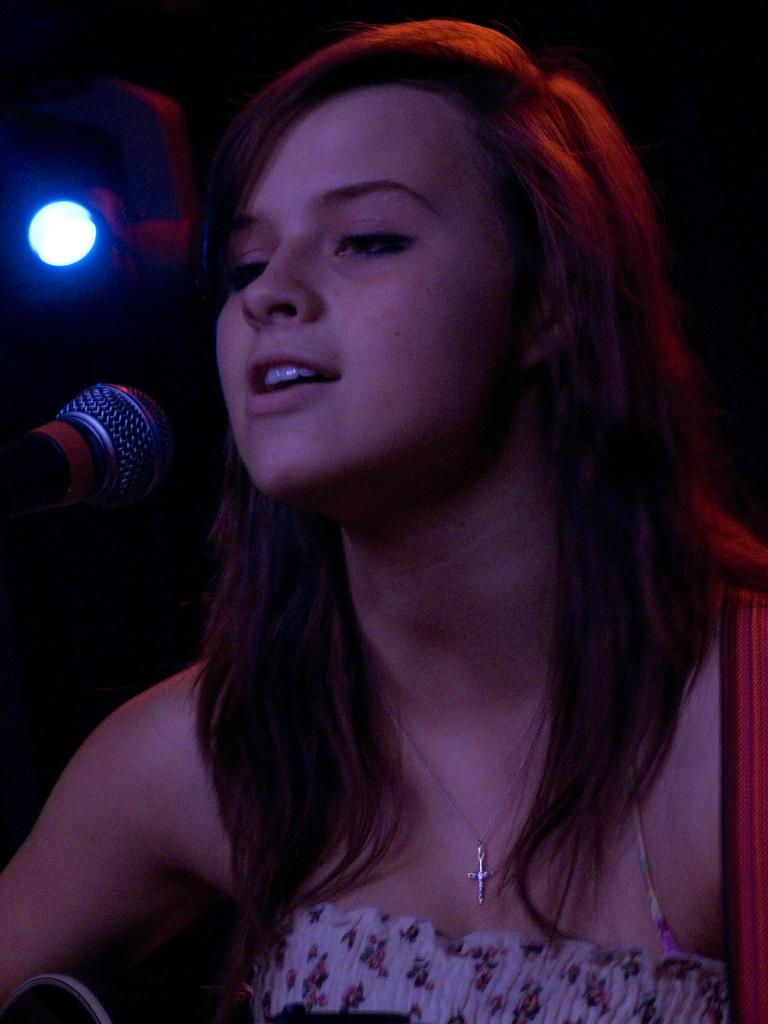Who is the main subject in the image? There is a woman in the image. What is the woman doing in the image? The woman is singing in the image. What object is the woman using while singing? The woman is in front of a microphone in the image. Can you describe the lighting in the image? There is a light in the left corner of the image. What type of island can be seen in the background of the image? There is no island present in the image; it features a woman singing in front of a microphone. How does the sidewalk contribute to the acoustics in the image? There is no sidewalk present in the image, so it cannot contribute to the acoustics. 